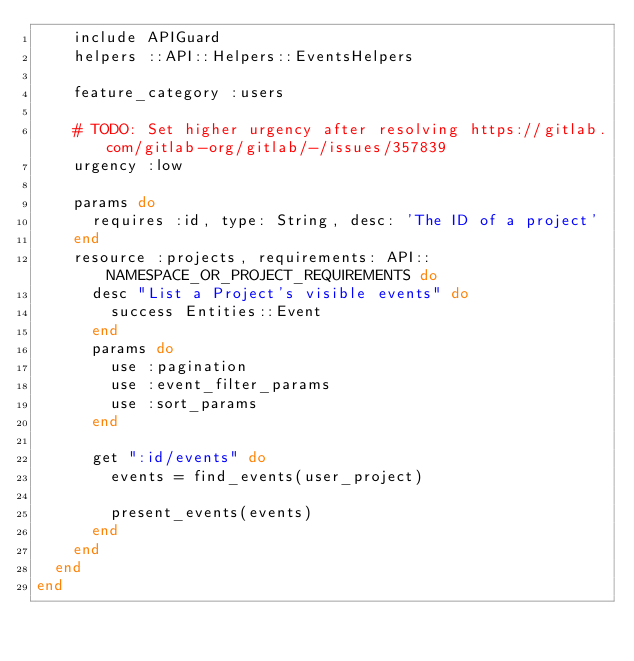Convert code to text. <code><loc_0><loc_0><loc_500><loc_500><_Ruby_>    include APIGuard
    helpers ::API::Helpers::EventsHelpers

    feature_category :users

    # TODO: Set higher urgency after resolving https://gitlab.com/gitlab-org/gitlab/-/issues/357839
    urgency :low

    params do
      requires :id, type: String, desc: 'The ID of a project'
    end
    resource :projects, requirements: API::NAMESPACE_OR_PROJECT_REQUIREMENTS do
      desc "List a Project's visible events" do
        success Entities::Event
      end
      params do
        use :pagination
        use :event_filter_params
        use :sort_params
      end

      get ":id/events" do
        events = find_events(user_project)

        present_events(events)
      end
    end
  end
end
</code> 